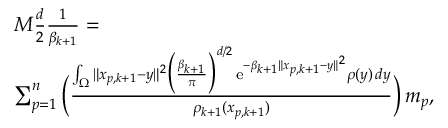<formula> <loc_0><loc_0><loc_500><loc_500>\begin{array} { r l } & { M \frac { d } { 2 } \frac { 1 } { \beta _ { k + 1 } } = } \\ & { \sum _ { p = 1 } ^ { n } \left ( \frac { \int _ { \Omega } \| x _ { p , k + 1 } - y \| ^ { 2 } \left ( \frac { \beta _ { k + 1 } } { \pi } \right ) ^ { d / 2 } \, e ^ { - \beta _ { k + 1 } \| x _ { p , k + 1 } - y \| ^ { 2 } } \rho ( y ) \, d y } { \rho _ { k + 1 } ( x _ { p , k + 1 } ) } \right ) \, m _ { p } , } \end{array}</formula> 